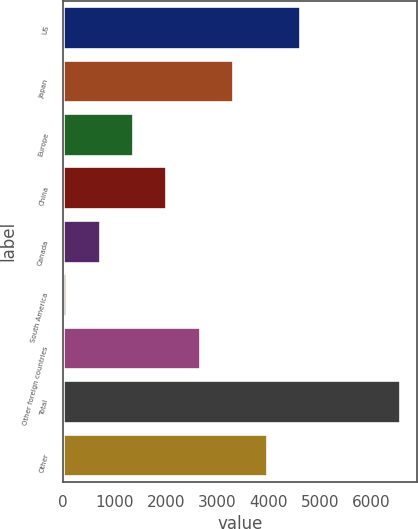<chart> <loc_0><loc_0><loc_500><loc_500><bar_chart><fcel>US<fcel>Japan<fcel>Europe<fcel>China<fcel>Canada<fcel>South America<fcel>Other foreign countries<fcel>Total<fcel>Other<nl><fcel>4607.4<fcel>3311<fcel>1366.4<fcel>2014.6<fcel>718.2<fcel>70<fcel>2662.8<fcel>6552<fcel>3959.2<nl></chart> 